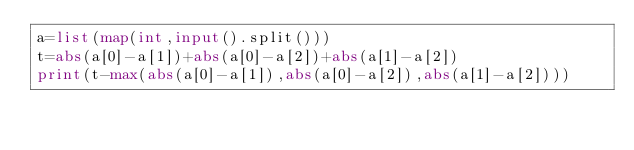Convert code to text. <code><loc_0><loc_0><loc_500><loc_500><_Python_>a=list(map(int,input().split()))
t=abs(a[0]-a[1])+abs(a[0]-a[2])+abs(a[1]-a[2])
print(t-max(abs(a[0]-a[1]),abs(a[0]-a[2]),abs(a[1]-a[2])))</code> 